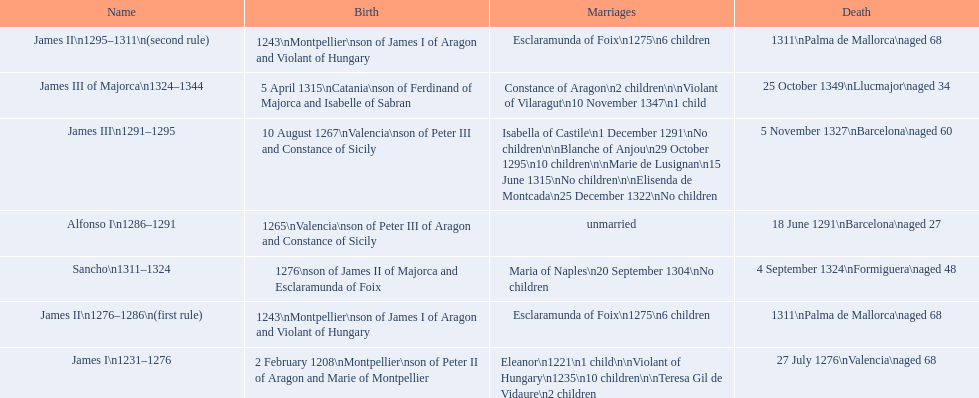How many of these monarchs died before the age of 65? 4. 